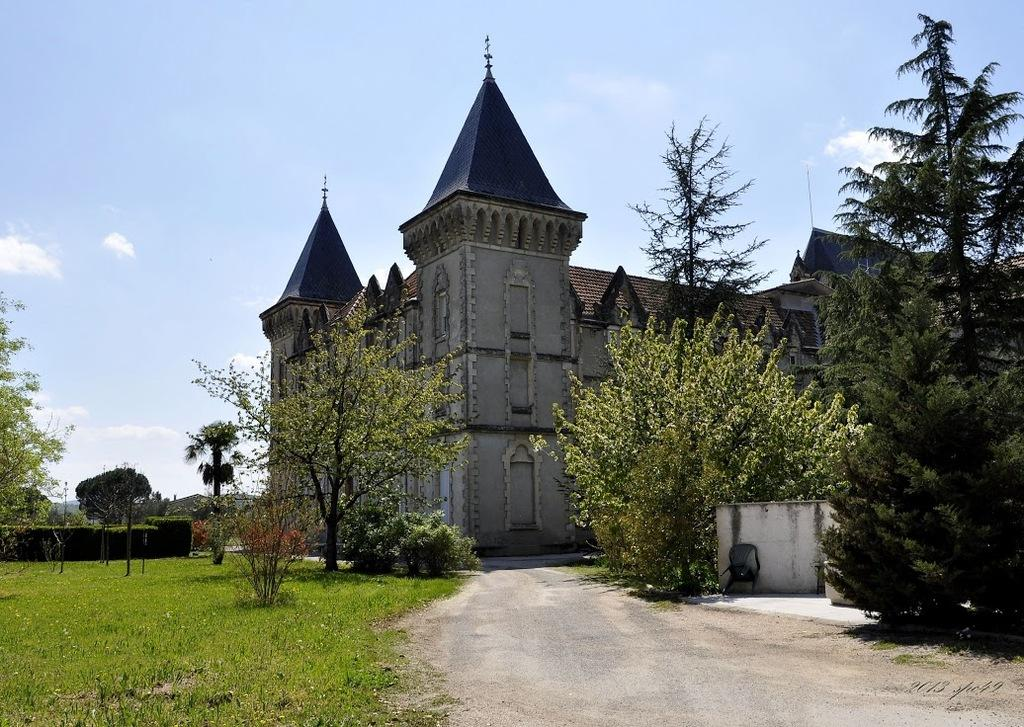What type of natural elements are present in the image? There are trees and plants in the image. What structure is located in the middle of the image? There is a building in the middle of the image. What is visible at the top of the image? The sky is visible at the top of the image. How many boats are visible in the image? There are no boats present in the image. What type of pencil can be seen in the image? There is no pencil present in the image. 